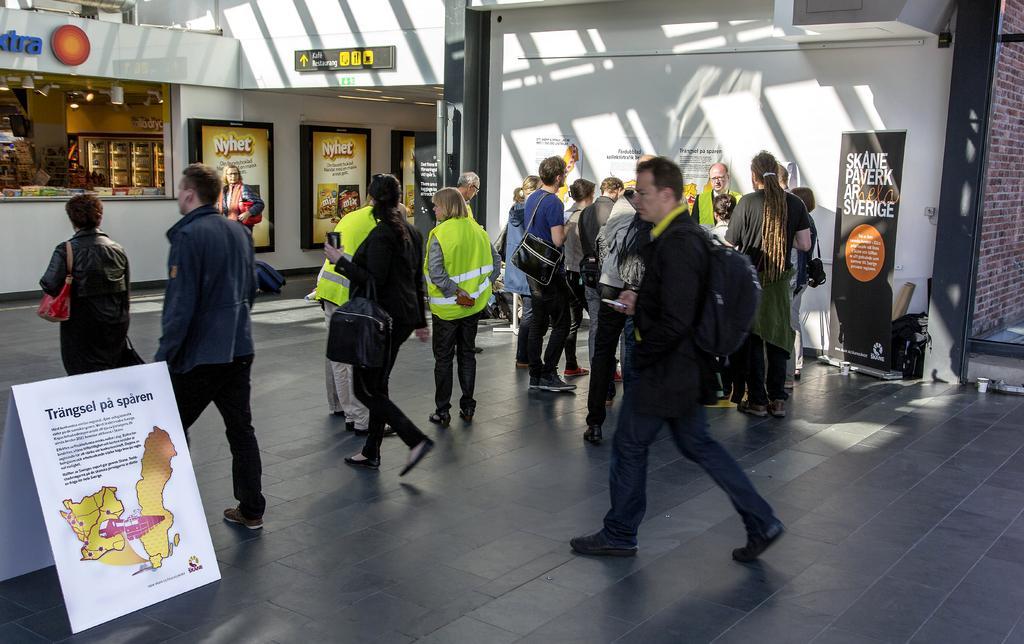Please provide a concise description of this image. In the picture we can see many people are walking and standing on the floor and some of them are wearing a jackets which are green in color and besides to them we can see some board on it we can see some information and map and in the background we can see a wall with some advertisement boards and a shop. 